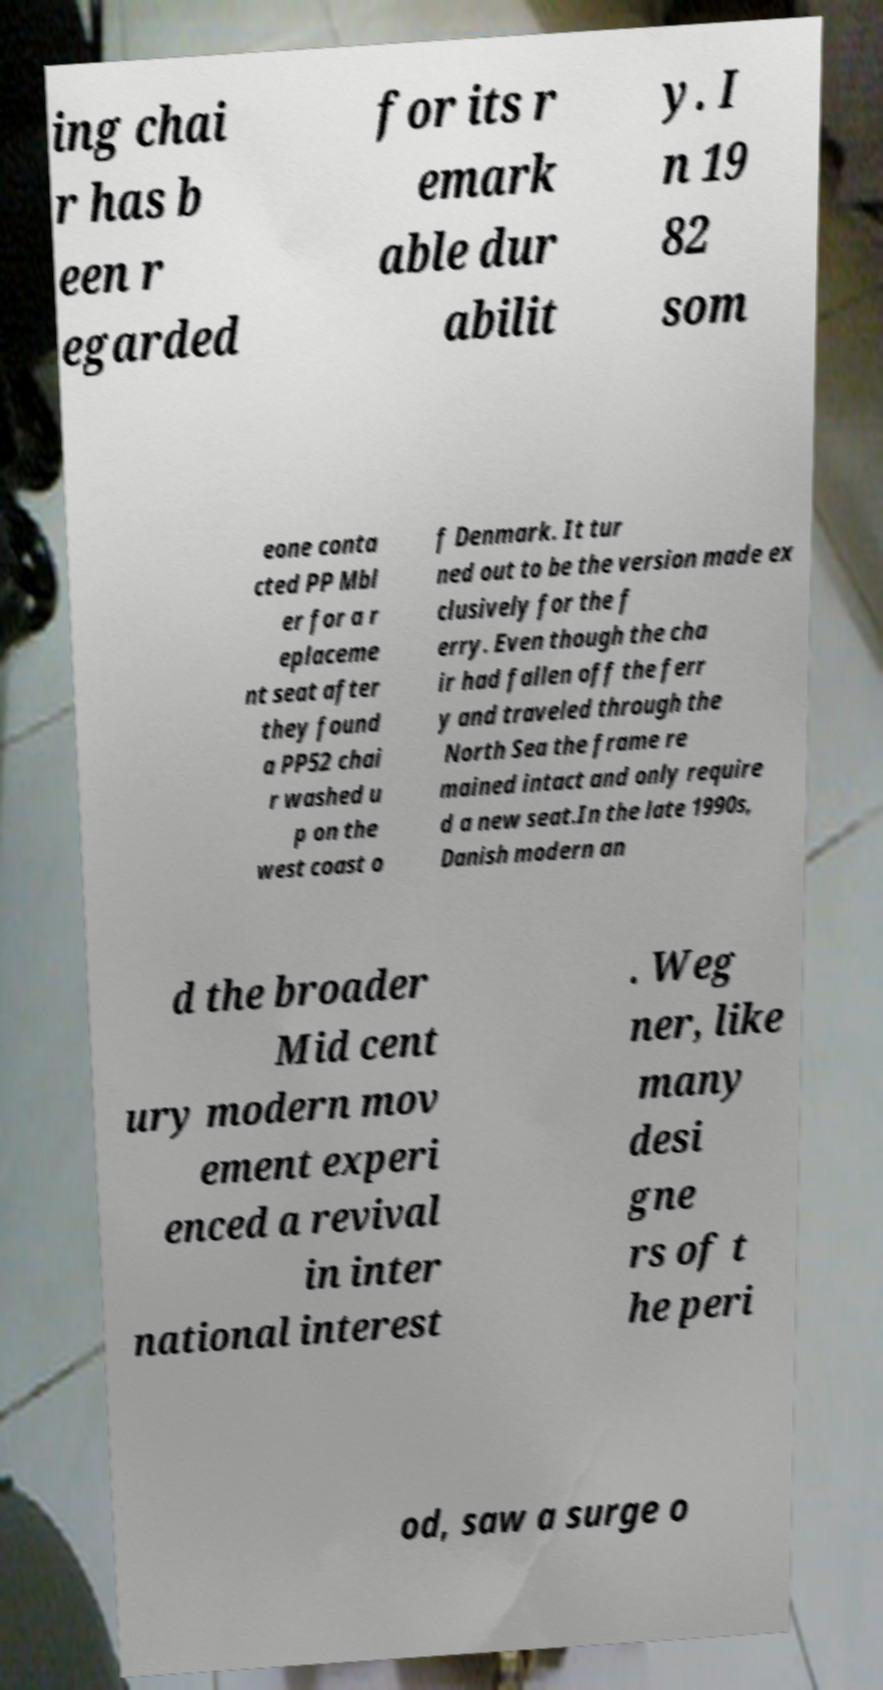Can you accurately transcribe the text from the provided image for me? ing chai r has b een r egarded for its r emark able dur abilit y. I n 19 82 som eone conta cted PP Mbl er for a r eplaceme nt seat after they found a PP52 chai r washed u p on the west coast o f Denmark. It tur ned out to be the version made ex clusively for the f erry. Even though the cha ir had fallen off the ferr y and traveled through the North Sea the frame re mained intact and only require d a new seat.In the late 1990s, Danish modern an d the broader Mid cent ury modern mov ement experi enced a revival in inter national interest . Weg ner, like many desi gne rs of t he peri od, saw a surge o 